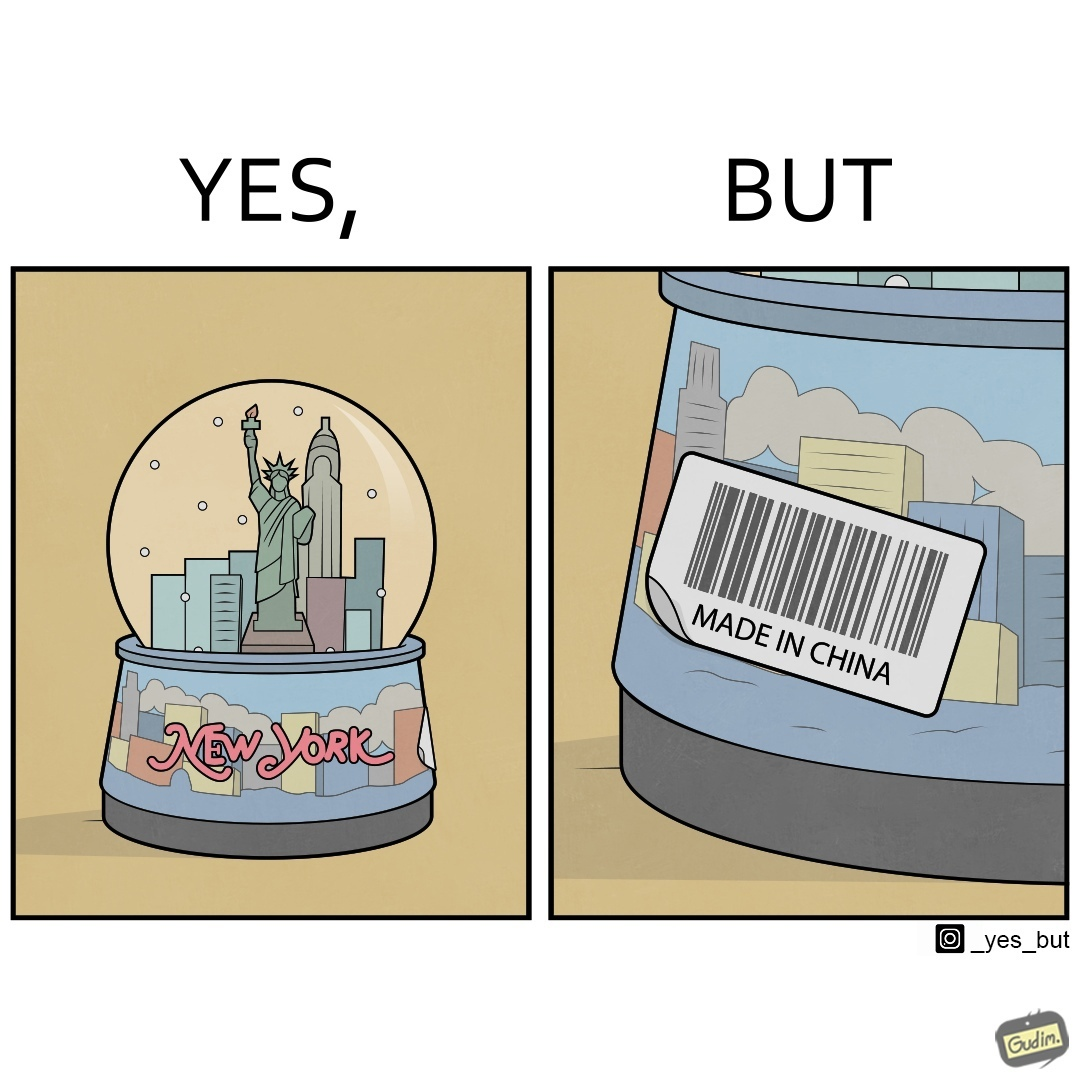Provide a description of this image. The image is ironic because the snowglobe says 'New York' while it is made in China 